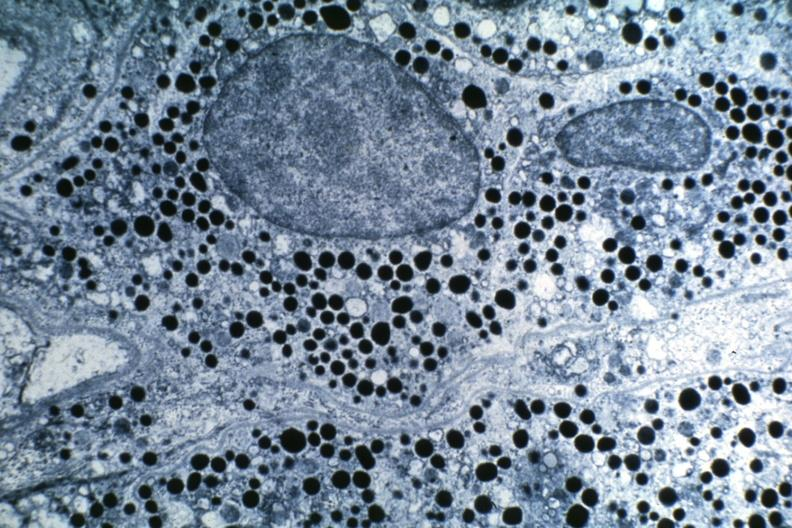s pituitary present?
Answer the question using a single word or phrase. Yes 